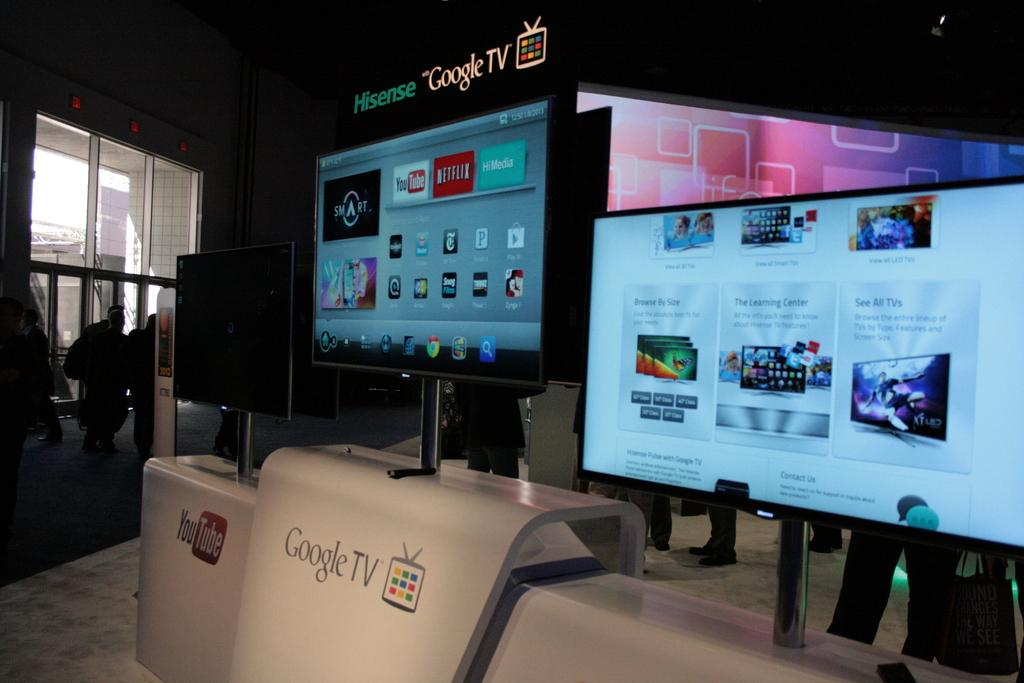<image>
Present a compact description of the photo's key features. A Hisense google tv is on a screen with the apps you tube and Netflix. 